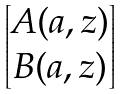Convert formula to latex. <formula><loc_0><loc_0><loc_500><loc_500>\begin{bmatrix} A ( a , z ) \\ B ( a , z ) \end{bmatrix}</formula> 